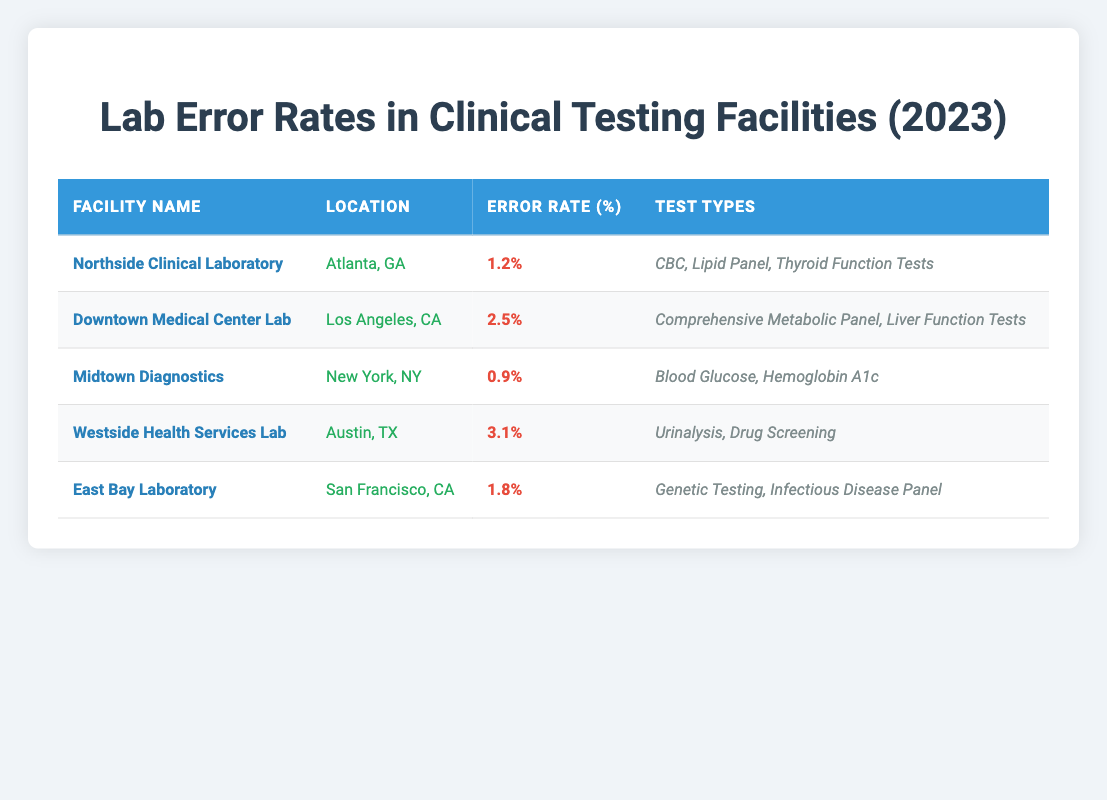What is the error rate for Midtown Diagnostics? According to the table, the error rate for Midtown Diagnostics is provided in the Error Rate column. It specifically states that the error rate is 0.9%.
Answer: 0.9% Which facility has the highest error rate? The facility with the highest error rate can be identified by comparing the Error Rate column. Westside Health Services Lab has the highest error rate at 3.1%.
Answer: Westside Health Services Lab What types of tests are offered by the Downtown Medical Center Lab? The table lists the test types offered by each facility in the Test Types column. For Downtown Medical Center Lab, the tests are Comprehensive Metabolic Panel and Liver Function Tests.
Answer: Comprehensive Metabolic Panel, Liver Function Tests Calculate the average error rate of all the listed facilities. To find the average error rate, sum the error rates (1.2 + 2.5 + 0.9 + 3.1 + 1.8 = 9.5) and then divide by the number of facilities (5). Thus, the average error rate is 9.5 / 5 = 1.9%.
Answer: 1.9% Is the error rate of Northside Clinical Laboratory less than 2%? Checking the Error Rate column for Northside Clinical Laboratory shows that the error rate is 1.2%, which is indeed less than 2%.
Answer: Yes Which labs are located in California? To find labs located in California, we examine the Location column. The facilities that mention California as their state are Downtown Medical Center Lab and East Bay Laboratory.
Answer: Downtown Medical Center Lab, East Bay Laboratory Do any facilities have an error rate above 2%? We can determine this by reviewing the Error Rate column for rates above 2%. From the table, Westside Health Services Lab (3.1%) meets this criterion.
Answer: Yes What are the test types associated with the East Bay Laboratory? The Test Types column provides the information needed. For East Bay Laboratory, the relevant tests are Genetic Testing and Infectious Disease Panel.
Answer: Genetic Testing, Infectious Disease Panel Which facility has a lower error rate: Northside Clinical Laboratory or East Bay Laboratory? By comparing the error rates in the Error Rate column, Northside Clinical Laboratory has an error rate of 1.2% while East Bay Laboratory has an error rate of 1.8%. Since 1.2% is less than 1.8%, Northside Clinical Laboratory has the lower error rate.
Answer: Northside Clinical Laboratory 